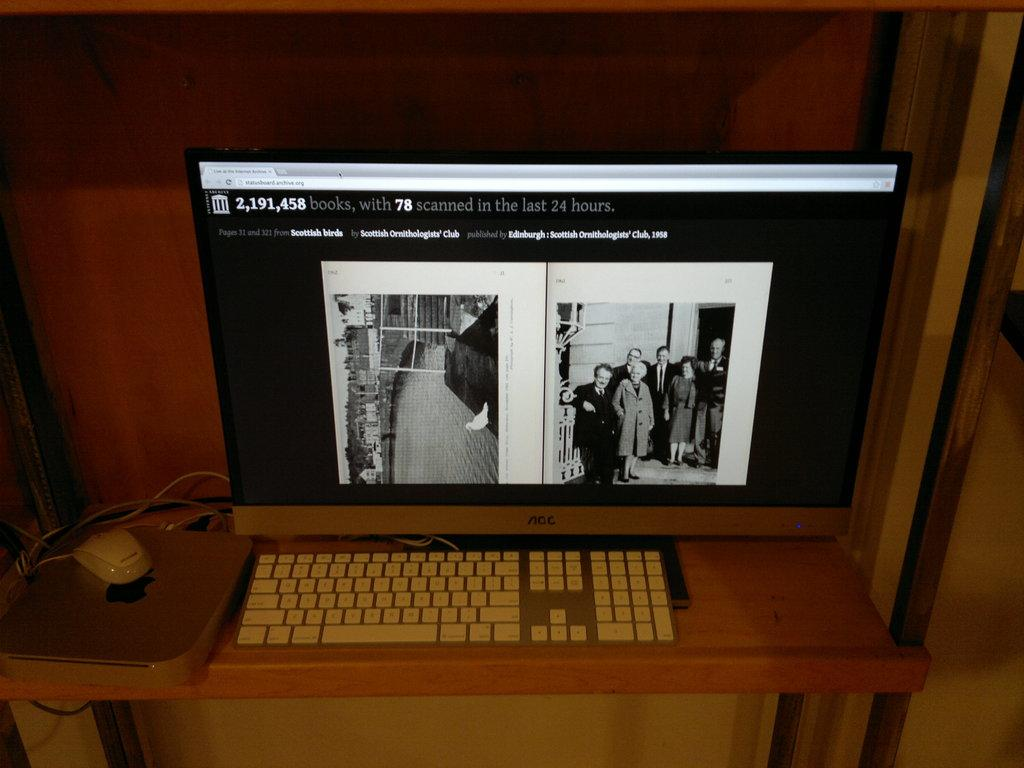What type of device is visible in the image? There is a keyboard in the image. What is another device that can be seen in the image? There is a computer mouse in the image. What is the third device present in the image? There is a monitor in the image. Where are these devices located? All these items are on a table. What type of prison can be seen in the image? There is no prison present in the image; it features a keyboard, computer mouse, and monitor on a table. How does the sun affect the devices in the image? The image does not show the sun or its effects on the devices, as it only features a keyboard, computer mouse, and monitor on a table. 